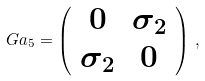<formula> <loc_0><loc_0><loc_500><loc_500>\ G a _ { 5 } = \left ( \begin{array} { c c } 0 & \sigma _ { 2 } \\ \sigma _ { 2 } & 0 \end{array} \right ) \, ,</formula> 